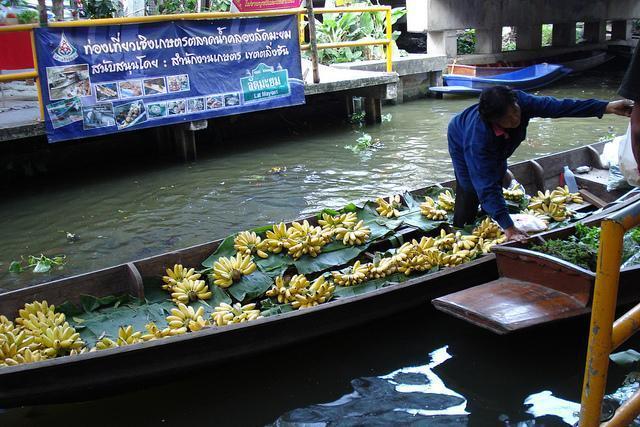How many boats are in the picture?
Give a very brief answer. 3. 